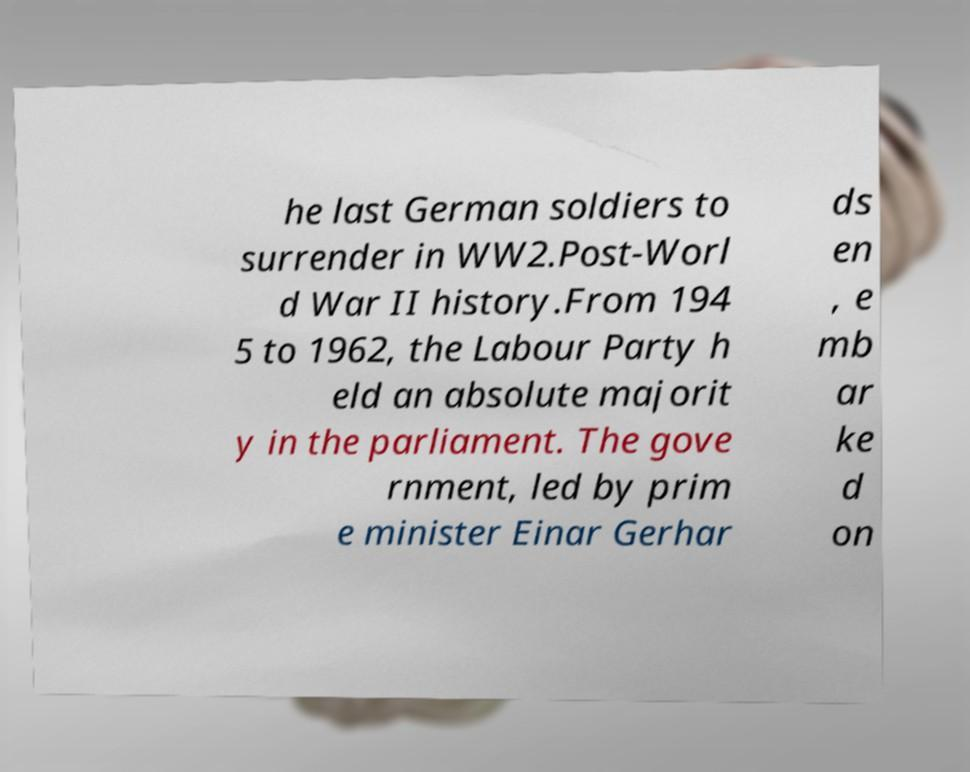Can you read and provide the text displayed in the image?This photo seems to have some interesting text. Can you extract and type it out for me? he last German soldiers to surrender in WW2.Post-Worl d War II history.From 194 5 to 1962, the Labour Party h eld an absolute majorit y in the parliament. The gove rnment, led by prim e minister Einar Gerhar ds en , e mb ar ke d on 